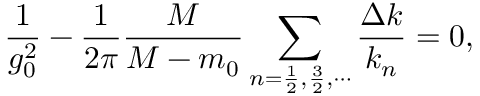<formula> <loc_0><loc_0><loc_500><loc_500>\frac { 1 } { g _ { 0 } ^ { 2 } } - \frac { 1 } { 2 \pi } \frac { M } { M - m _ { 0 } } \sum _ { n = \frac { 1 } { 2 } , \frac { 3 } { 2 } , \cdots } \frac { \Delta k } { k _ { n } } = 0 ,</formula> 